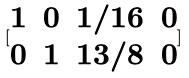<formula> <loc_0><loc_0><loc_500><loc_500>[ \begin{matrix} 1 & 0 & 1 / 1 6 & 0 \\ 0 & 1 & 1 3 / 8 & 0 \end{matrix} ]</formula> 